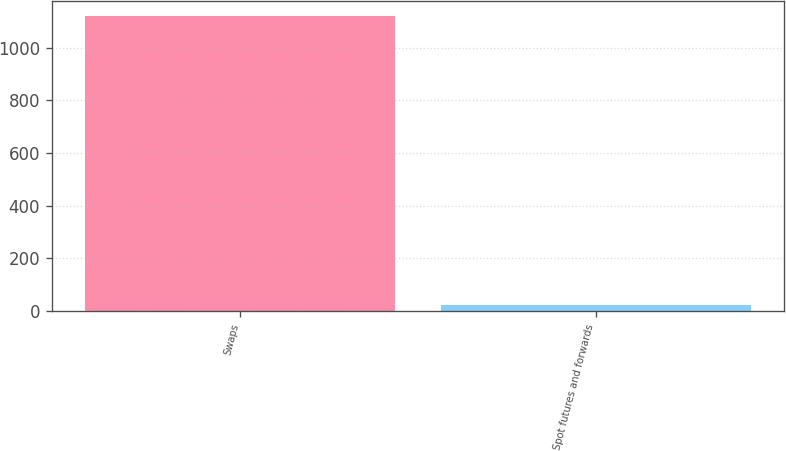Convert chart. <chart><loc_0><loc_0><loc_500><loc_500><bar_chart><fcel>Swaps<fcel>Spot futures and forwards<nl><fcel>1121.3<fcel>24.6<nl></chart> 